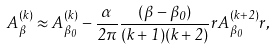Convert formula to latex. <formula><loc_0><loc_0><loc_500><loc_500>A ^ { ( k ) } _ { \beta } \approx A ^ { ( k ) } _ { \beta _ { 0 } } - \frac { \alpha } { 2 \pi } \frac { ( \beta - \beta _ { 0 } ) } { ( k + 1 ) ( k + 2 ) } { r } A ^ { ( k + 2 ) } _ { \beta _ { 0 } } { r } ,</formula> 